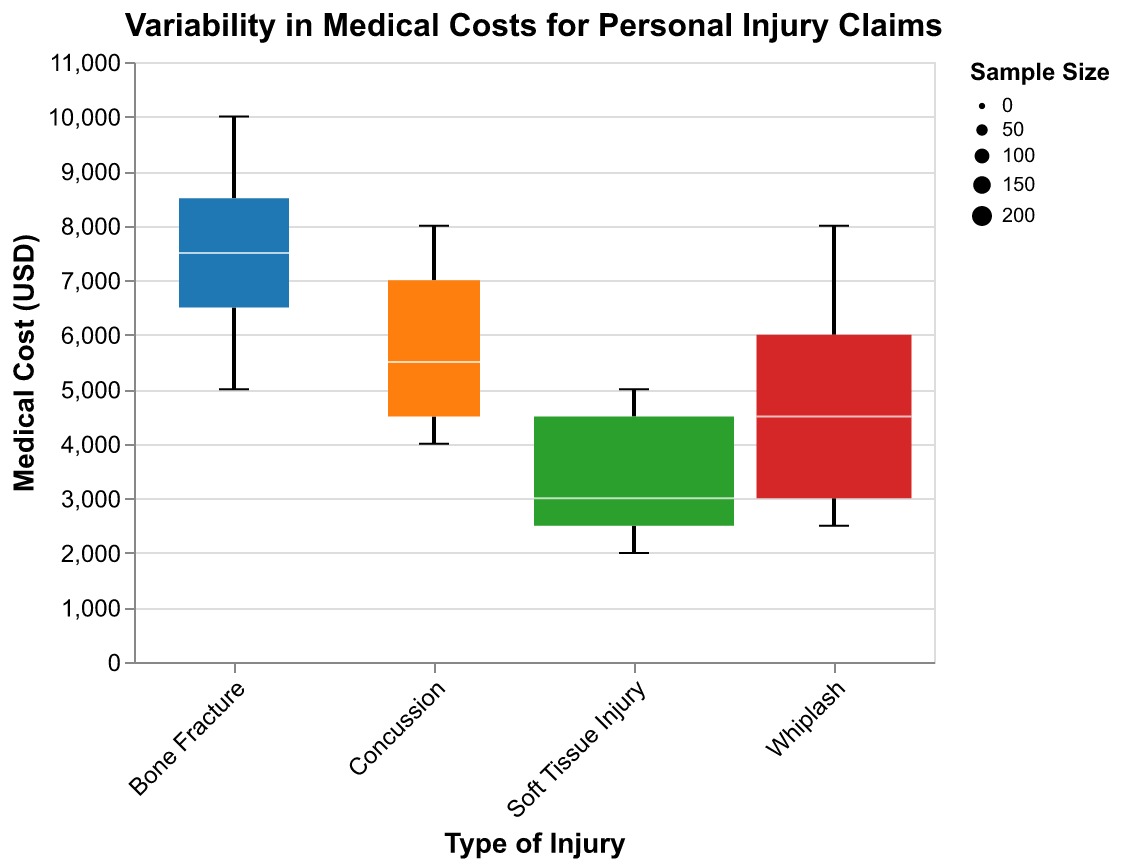What is the title of the figure? The title is usually displayed at the top of the figure. In this case, it reads "Variability in Medical Costs for Personal Injury Claims".
Answer: Variability in Medical Costs for Personal Injury Claims What is the range of medical costs for whiplash injuries? To determine the range, look at the lowest and highest points for the whiplash box plot on the y-axis, which ranges from 2500 to 8000 USD.
Answer: 2500 to 8000 USD Which injury type has the largest median medical cost? Identify the thick white median lines within each box plot and locate the one positioned highest on the y-axis. For bone fractures, the median line is at the highest value, approximately around 7500 USD.
Answer: Bone Fracture Which type of injury has the widest interquartile range (IQR)? Compare the lengths of the boxes (which represent the IQR) for each injury type. The longest box among them is for bone fractures.
Answer: Bone Fracture How does the sample size for whiplash injuries compare to the sample size for concussion injuries? The width of the boxes represents sample sizes: Whiplash has a wider box than Concussion, implying a larger sample size. Whiplash has 150, and Concussion has 80.
Answer: Whiplash has a larger sample size than Concussion What is the approximate median medical cost for soft tissue injuries? Locate the thick white median line within the soft tissue injury box plot; it is approximately between 2500 USD and 3000 USD.
Answer: Approximately 3000 USD Between whiplash and soft tissue injuries, which one has higher variability in medical costs? Higher variability is indicated by a larger spread (whiskers) from the minimum to maximum. Whiplash has whiskers ranging from 2500 to 8000, while soft tissue injuries range from 2000 to 5000.
Answer: Whiplash Which type of injury has the smallest median medical cost? Identify and compare the position of each median line within the box plots. Soft tissue injuries have the lowest position on the y-axis.
Answer: Soft Tissue Injury Which type of injury has the narrowest interquartile range (IQR)? Compare the lengths of the boxes for each injury type. The shortest box is for soft tissue injuries.
Answer: Soft Tissue Injury What is the maximum medical cost for concussions based on the plot? Look at the highest point (whisker) on the concussion box plot; it reaches up to 8000 USD.
Answer: 8000 USD 